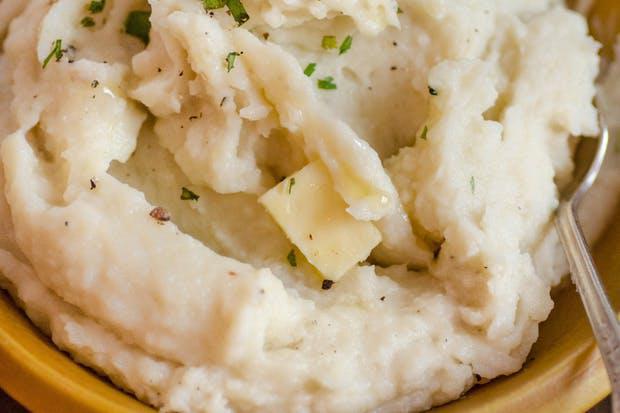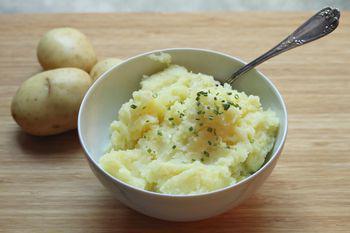The first image is the image on the left, the second image is the image on the right. Evaluate the accuracy of this statement regarding the images: "The potatoes in the image on the left are served in a square shaped bowl.". Is it true? Answer yes or no. No. The first image is the image on the left, the second image is the image on the right. Analyze the images presented: Is the assertion "Mashed potatoes are in a squared white dish in one image." valid? Answer yes or no. No. 